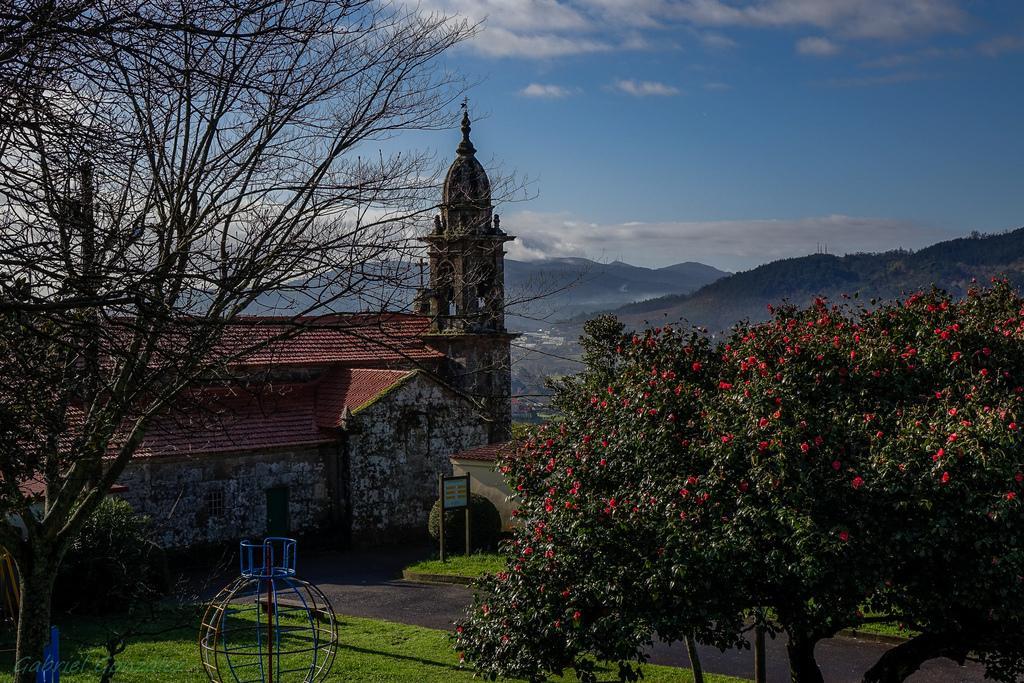Please provide a concise description of this image. In this image we can see trees, grass, boards, house, hills and the blue color sky with clouds in the background. 